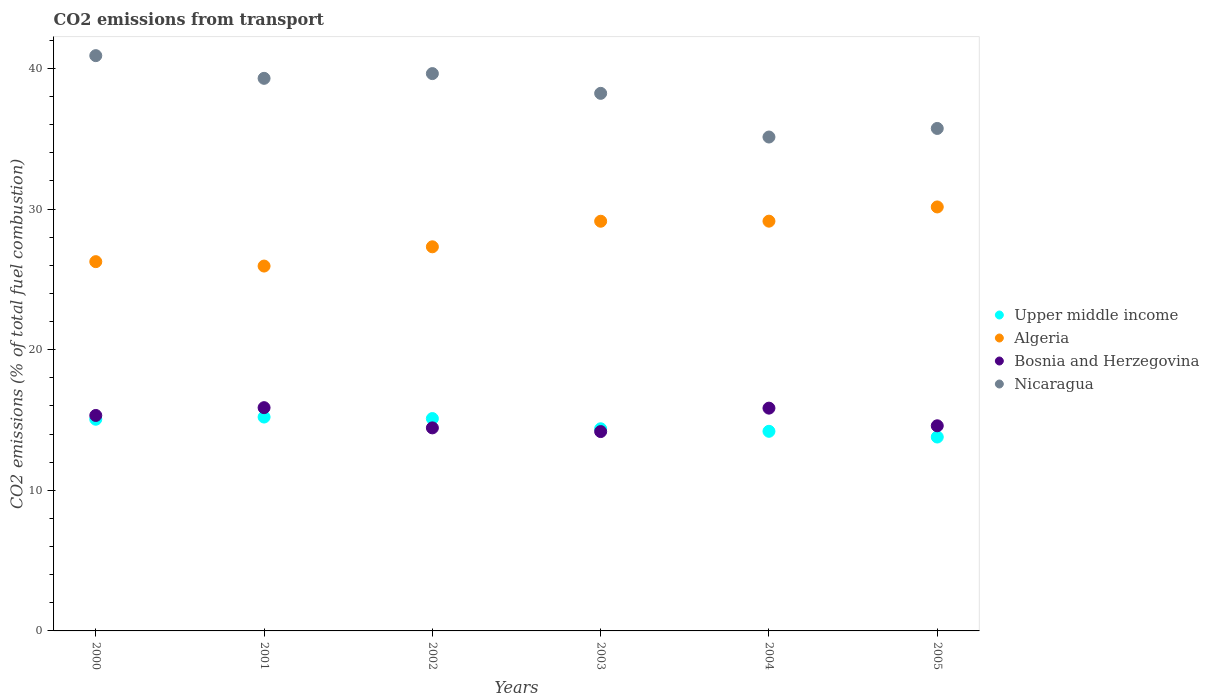How many different coloured dotlines are there?
Offer a very short reply. 4. Is the number of dotlines equal to the number of legend labels?
Your response must be concise. Yes. What is the total CO2 emitted in Algeria in 2003?
Keep it short and to the point. 29.13. Across all years, what is the maximum total CO2 emitted in Algeria?
Make the answer very short. 30.15. Across all years, what is the minimum total CO2 emitted in Upper middle income?
Ensure brevity in your answer.  13.79. In which year was the total CO2 emitted in Bosnia and Herzegovina maximum?
Your answer should be very brief. 2001. In which year was the total CO2 emitted in Algeria minimum?
Provide a succinct answer. 2001. What is the total total CO2 emitted in Bosnia and Herzegovina in the graph?
Make the answer very short. 90.24. What is the difference between the total CO2 emitted in Bosnia and Herzegovina in 2002 and that in 2003?
Your answer should be very brief. 0.26. What is the difference between the total CO2 emitted in Bosnia and Herzegovina in 2004 and the total CO2 emitted in Upper middle income in 2005?
Provide a succinct answer. 2.05. What is the average total CO2 emitted in Algeria per year?
Ensure brevity in your answer.  27.99. In the year 2000, what is the difference between the total CO2 emitted in Nicaragua and total CO2 emitted in Algeria?
Your answer should be compact. 14.65. In how many years, is the total CO2 emitted in Bosnia and Herzegovina greater than 24?
Provide a succinct answer. 0. What is the ratio of the total CO2 emitted in Algeria in 2001 to that in 2005?
Provide a short and direct response. 0.86. Is the difference between the total CO2 emitted in Nicaragua in 2001 and 2004 greater than the difference between the total CO2 emitted in Algeria in 2001 and 2004?
Give a very brief answer. Yes. What is the difference between the highest and the second highest total CO2 emitted in Nicaragua?
Provide a short and direct response. 1.28. What is the difference between the highest and the lowest total CO2 emitted in Bosnia and Herzegovina?
Your answer should be very brief. 1.7. Is the sum of the total CO2 emitted in Algeria in 2001 and 2003 greater than the maximum total CO2 emitted in Nicaragua across all years?
Keep it short and to the point. Yes. Is it the case that in every year, the sum of the total CO2 emitted in Nicaragua and total CO2 emitted in Bosnia and Herzegovina  is greater than the total CO2 emitted in Upper middle income?
Offer a terse response. Yes. Does the total CO2 emitted in Nicaragua monotonically increase over the years?
Ensure brevity in your answer.  No. Is the total CO2 emitted in Bosnia and Herzegovina strictly greater than the total CO2 emitted in Upper middle income over the years?
Offer a very short reply. No. How many dotlines are there?
Offer a terse response. 4. What is the difference between two consecutive major ticks on the Y-axis?
Provide a short and direct response. 10. How many legend labels are there?
Make the answer very short. 4. How are the legend labels stacked?
Your answer should be compact. Vertical. What is the title of the graph?
Your response must be concise. CO2 emissions from transport. What is the label or title of the Y-axis?
Ensure brevity in your answer.  CO2 emissions (% of total fuel combustion). What is the CO2 emissions (% of total fuel combustion) of Upper middle income in 2000?
Offer a very short reply. 15.05. What is the CO2 emissions (% of total fuel combustion) of Algeria in 2000?
Offer a very short reply. 26.26. What is the CO2 emissions (% of total fuel combustion) in Bosnia and Herzegovina in 2000?
Give a very brief answer. 15.32. What is the CO2 emissions (% of total fuel combustion) of Nicaragua in 2000?
Your response must be concise. 40.91. What is the CO2 emissions (% of total fuel combustion) in Upper middle income in 2001?
Keep it short and to the point. 15.21. What is the CO2 emissions (% of total fuel combustion) of Algeria in 2001?
Provide a short and direct response. 25.95. What is the CO2 emissions (% of total fuel combustion) of Bosnia and Herzegovina in 2001?
Give a very brief answer. 15.88. What is the CO2 emissions (% of total fuel combustion) in Nicaragua in 2001?
Provide a succinct answer. 39.3. What is the CO2 emissions (% of total fuel combustion) in Upper middle income in 2002?
Provide a succinct answer. 15.1. What is the CO2 emissions (% of total fuel combustion) in Algeria in 2002?
Ensure brevity in your answer.  27.32. What is the CO2 emissions (% of total fuel combustion) of Bosnia and Herzegovina in 2002?
Keep it short and to the point. 14.44. What is the CO2 emissions (% of total fuel combustion) in Nicaragua in 2002?
Your response must be concise. 39.63. What is the CO2 emissions (% of total fuel combustion) in Upper middle income in 2003?
Your response must be concise. 14.38. What is the CO2 emissions (% of total fuel combustion) in Algeria in 2003?
Offer a very short reply. 29.13. What is the CO2 emissions (% of total fuel combustion) in Bosnia and Herzegovina in 2003?
Offer a very short reply. 14.18. What is the CO2 emissions (% of total fuel combustion) in Nicaragua in 2003?
Make the answer very short. 38.23. What is the CO2 emissions (% of total fuel combustion) in Upper middle income in 2004?
Keep it short and to the point. 14.2. What is the CO2 emissions (% of total fuel combustion) of Algeria in 2004?
Offer a terse response. 29.14. What is the CO2 emissions (% of total fuel combustion) in Bosnia and Herzegovina in 2004?
Provide a short and direct response. 15.84. What is the CO2 emissions (% of total fuel combustion) of Nicaragua in 2004?
Make the answer very short. 35.12. What is the CO2 emissions (% of total fuel combustion) of Upper middle income in 2005?
Ensure brevity in your answer.  13.79. What is the CO2 emissions (% of total fuel combustion) of Algeria in 2005?
Make the answer very short. 30.15. What is the CO2 emissions (% of total fuel combustion) of Bosnia and Herzegovina in 2005?
Offer a very short reply. 14.59. What is the CO2 emissions (% of total fuel combustion) in Nicaragua in 2005?
Offer a very short reply. 35.73. Across all years, what is the maximum CO2 emissions (% of total fuel combustion) in Upper middle income?
Make the answer very short. 15.21. Across all years, what is the maximum CO2 emissions (% of total fuel combustion) in Algeria?
Your answer should be compact. 30.15. Across all years, what is the maximum CO2 emissions (% of total fuel combustion) of Bosnia and Herzegovina?
Provide a succinct answer. 15.88. Across all years, what is the maximum CO2 emissions (% of total fuel combustion) in Nicaragua?
Your answer should be compact. 40.91. Across all years, what is the minimum CO2 emissions (% of total fuel combustion) of Upper middle income?
Keep it short and to the point. 13.79. Across all years, what is the minimum CO2 emissions (% of total fuel combustion) in Algeria?
Give a very brief answer. 25.95. Across all years, what is the minimum CO2 emissions (% of total fuel combustion) of Bosnia and Herzegovina?
Your answer should be compact. 14.18. Across all years, what is the minimum CO2 emissions (% of total fuel combustion) of Nicaragua?
Your response must be concise. 35.12. What is the total CO2 emissions (% of total fuel combustion) in Upper middle income in the graph?
Your answer should be compact. 87.72. What is the total CO2 emissions (% of total fuel combustion) in Algeria in the graph?
Provide a short and direct response. 167.94. What is the total CO2 emissions (% of total fuel combustion) of Bosnia and Herzegovina in the graph?
Give a very brief answer. 90.24. What is the total CO2 emissions (% of total fuel combustion) in Nicaragua in the graph?
Keep it short and to the point. 228.92. What is the difference between the CO2 emissions (% of total fuel combustion) in Upper middle income in 2000 and that in 2001?
Offer a very short reply. -0.16. What is the difference between the CO2 emissions (% of total fuel combustion) of Algeria in 2000 and that in 2001?
Give a very brief answer. 0.31. What is the difference between the CO2 emissions (% of total fuel combustion) of Bosnia and Herzegovina in 2000 and that in 2001?
Provide a short and direct response. -0.55. What is the difference between the CO2 emissions (% of total fuel combustion) in Nicaragua in 2000 and that in 2001?
Your answer should be compact. 1.61. What is the difference between the CO2 emissions (% of total fuel combustion) of Upper middle income in 2000 and that in 2002?
Offer a very short reply. -0.05. What is the difference between the CO2 emissions (% of total fuel combustion) of Algeria in 2000 and that in 2002?
Offer a very short reply. -1.06. What is the difference between the CO2 emissions (% of total fuel combustion) of Bosnia and Herzegovina in 2000 and that in 2002?
Your response must be concise. 0.88. What is the difference between the CO2 emissions (% of total fuel combustion) of Nicaragua in 2000 and that in 2002?
Offer a very short reply. 1.28. What is the difference between the CO2 emissions (% of total fuel combustion) in Upper middle income in 2000 and that in 2003?
Make the answer very short. 0.68. What is the difference between the CO2 emissions (% of total fuel combustion) in Algeria in 2000 and that in 2003?
Give a very brief answer. -2.87. What is the difference between the CO2 emissions (% of total fuel combustion) of Bosnia and Herzegovina in 2000 and that in 2003?
Your answer should be very brief. 1.15. What is the difference between the CO2 emissions (% of total fuel combustion) in Nicaragua in 2000 and that in 2003?
Offer a terse response. 2.68. What is the difference between the CO2 emissions (% of total fuel combustion) in Upper middle income in 2000 and that in 2004?
Your response must be concise. 0.86. What is the difference between the CO2 emissions (% of total fuel combustion) of Algeria in 2000 and that in 2004?
Provide a succinct answer. -2.88. What is the difference between the CO2 emissions (% of total fuel combustion) of Bosnia and Herzegovina in 2000 and that in 2004?
Provide a short and direct response. -0.52. What is the difference between the CO2 emissions (% of total fuel combustion) in Nicaragua in 2000 and that in 2004?
Offer a terse response. 5.79. What is the difference between the CO2 emissions (% of total fuel combustion) in Upper middle income in 2000 and that in 2005?
Your answer should be very brief. 1.26. What is the difference between the CO2 emissions (% of total fuel combustion) in Algeria in 2000 and that in 2005?
Your response must be concise. -3.89. What is the difference between the CO2 emissions (% of total fuel combustion) in Bosnia and Herzegovina in 2000 and that in 2005?
Keep it short and to the point. 0.73. What is the difference between the CO2 emissions (% of total fuel combustion) of Nicaragua in 2000 and that in 2005?
Ensure brevity in your answer.  5.18. What is the difference between the CO2 emissions (% of total fuel combustion) of Upper middle income in 2001 and that in 2002?
Make the answer very short. 0.11. What is the difference between the CO2 emissions (% of total fuel combustion) in Algeria in 2001 and that in 2002?
Provide a short and direct response. -1.37. What is the difference between the CO2 emissions (% of total fuel combustion) of Bosnia and Herzegovina in 2001 and that in 2002?
Your response must be concise. 1.44. What is the difference between the CO2 emissions (% of total fuel combustion) of Nicaragua in 2001 and that in 2002?
Keep it short and to the point. -0.34. What is the difference between the CO2 emissions (% of total fuel combustion) of Upper middle income in 2001 and that in 2003?
Keep it short and to the point. 0.83. What is the difference between the CO2 emissions (% of total fuel combustion) of Algeria in 2001 and that in 2003?
Provide a succinct answer. -3.19. What is the difference between the CO2 emissions (% of total fuel combustion) in Bosnia and Herzegovina in 2001 and that in 2003?
Keep it short and to the point. 1.7. What is the difference between the CO2 emissions (% of total fuel combustion) of Nicaragua in 2001 and that in 2003?
Give a very brief answer. 1.07. What is the difference between the CO2 emissions (% of total fuel combustion) of Upper middle income in 2001 and that in 2004?
Your response must be concise. 1.01. What is the difference between the CO2 emissions (% of total fuel combustion) in Algeria in 2001 and that in 2004?
Give a very brief answer. -3.19. What is the difference between the CO2 emissions (% of total fuel combustion) of Bosnia and Herzegovina in 2001 and that in 2004?
Offer a very short reply. 0.03. What is the difference between the CO2 emissions (% of total fuel combustion) in Nicaragua in 2001 and that in 2004?
Ensure brevity in your answer.  4.17. What is the difference between the CO2 emissions (% of total fuel combustion) of Upper middle income in 2001 and that in 2005?
Provide a succinct answer. 1.42. What is the difference between the CO2 emissions (% of total fuel combustion) of Algeria in 2001 and that in 2005?
Keep it short and to the point. -4.2. What is the difference between the CO2 emissions (% of total fuel combustion) in Bosnia and Herzegovina in 2001 and that in 2005?
Your answer should be compact. 1.29. What is the difference between the CO2 emissions (% of total fuel combustion) of Nicaragua in 2001 and that in 2005?
Your answer should be compact. 3.56. What is the difference between the CO2 emissions (% of total fuel combustion) of Upper middle income in 2002 and that in 2003?
Your response must be concise. 0.73. What is the difference between the CO2 emissions (% of total fuel combustion) of Algeria in 2002 and that in 2003?
Give a very brief answer. -1.82. What is the difference between the CO2 emissions (% of total fuel combustion) in Bosnia and Herzegovina in 2002 and that in 2003?
Offer a very short reply. 0.26. What is the difference between the CO2 emissions (% of total fuel combustion) in Nicaragua in 2002 and that in 2003?
Your response must be concise. 1.4. What is the difference between the CO2 emissions (% of total fuel combustion) of Upper middle income in 2002 and that in 2004?
Provide a succinct answer. 0.91. What is the difference between the CO2 emissions (% of total fuel combustion) of Algeria in 2002 and that in 2004?
Keep it short and to the point. -1.82. What is the difference between the CO2 emissions (% of total fuel combustion) of Bosnia and Herzegovina in 2002 and that in 2004?
Your response must be concise. -1.4. What is the difference between the CO2 emissions (% of total fuel combustion) of Nicaragua in 2002 and that in 2004?
Provide a short and direct response. 4.51. What is the difference between the CO2 emissions (% of total fuel combustion) in Upper middle income in 2002 and that in 2005?
Make the answer very short. 1.31. What is the difference between the CO2 emissions (% of total fuel combustion) in Algeria in 2002 and that in 2005?
Make the answer very short. -2.83. What is the difference between the CO2 emissions (% of total fuel combustion) of Bosnia and Herzegovina in 2002 and that in 2005?
Provide a succinct answer. -0.15. What is the difference between the CO2 emissions (% of total fuel combustion) in Nicaragua in 2002 and that in 2005?
Offer a terse response. 3.9. What is the difference between the CO2 emissions (% of total fuel combustion) in Upper middle income in 2003 and that in 2004?
Offer a terse response. 0.18. What is the difference between the CO2 emissions (% of total fuel combustion) of Algeria in 2003 and that in 2004?
Your answer should be compact. -0. What is the difference between the CO2 emissions (% of total fuel combustion) in Bosnia and Herzegovina in 2003 and that in 2004?
Provide a short and direct response. -1.67. What is the difference between the CO2 emissions (% of total fuel combustion) of Nicaragua in 2003 and that in 2004?
Ensure brevity in your answer.  3.11. What is the difference between the CO2 emissions (% of total fuel combustion) in Upper middle income in 2003 and that in 2005?
Your answer should be very brief. 0.59. What is the difference between the CO2 emissions (% of total fuel combustion) of Algeria in 2003 and that in 2005?
Your answer should be very brief. -1.02. What is the difference between the CO2 emissions (% of total fuel combustion) of Bosnia and Herzegovina in 2003 and that in 2005?
Offer a very short reply. -0.41. What is the difference between the CO2 emissions (% of total fuel combustion) of Nicaragua in 2003 and that in 2005?
Offer a terse response. 2.5. What is the difference between the CO2 emissions (% of total fuel combustion) in Upper middle income in 2004 and that in 2005?
Your answer should be very brief. 0.41. What is the difference between the CO2 emissions (% of total fuel combustion) of Algeria in 2004 and that in 2005?
Ensure brevity in your answer.  -1.01. What is the difference between the CO2 emissions (% of total fuel combustion) in Bosnia and Herzegovina in 2004 and that in 2005?
Offer a terse response. 1.25. What is the difference between the CO2 emissions (% of total fuel combustion) in Nicaragua in 2004 and that in 2005?
Provide a succinct answer. -0.61. What is the difference between the CO2 emissions (% of total fuel combustion) in Upper middle income in 2000 and the CO2 emissions (% of total fuel combustion) in Algeria in 2001?
Give a very brief answer. -10.89. What is the difference between the CO2 emissions (% of total fuel combustion) of Upper middle income in 2000 and the CO2 emissions (% of total fuel combustion) of Bosnia and Herzegovina in 2001?
Make the answer very short. -0.82. What is the difference between the CO2 emissions (% of total fuel combustion) in Upper middle income in 2000 and the CO2 emissions (% of total fuel combustion) in Nicaragua in 2001?
Your answer should be compact. -24.24. What is the difference between the CO2 emissions (% of total fuel combustion) in Algeria in 2000 and the CO2 emissions (% of total fuel combustion) in Bosnia and Herzegovina in 2001?
Offer a very short reply. 10.38. What is the difference between the CO2 emissions (% of total fuel combustion) in Algeria in 2000 and the CO2 emissions (% of total fuel combustion) in Nicaragua in 2001?
Offer a very short reply. -13.04. What is the difference between the CO2 emissions (% of total fuel combustion) in Bosnia and Herzegovina in 2000 and the CO2 emissions (% of total fuel combustion) in Nicaragua in 2001?
Give a very brief answer. -23.97. What is the difference between the CO2 emissions (% of total fuel combustion) of Upper middle income in 2000 and the CO2 emissions (% of total fuel combustion) of Algeria in 2002?
Offer a terse response. -12.26. What is the difference between the CO2 emissions (% of total fuel combustion) in Upper middle income in 2000 and the CO2 emissions (% of total fuel combustion) in Bosnia and Herzegovina in 2002?
Your response must be concise. 0.61. What is the difference between the CO2 emissions (% of total fuel combustion) of Upper middle income in 2000 and the CO2 emissions (% of total fuel combustion) of Nicaragua in 2002?
Ensure brevity in your answer.  -24.58. What is the difference between the CO2 emissions (% of total fuel combustion) of Algeria in 2000 and the CO2 emissions (% of total fuel combustion) of Bosnia and Herzegovina in 2002?
Provide a succinct answer. 11.82. What is the difference between the CO2 emissions (% of total fuel combustion) in Algeria in 2000 and the CO2 emissions (% of total fuel combustion) in Nicaragua in 2002?
Provide a short and direct response. -13.37. What is the difference between the CO2 emissions (% of total fuel combustion) of Bosnia and Herzegovina in 2000 and the CO2 emissions (% of total fuel combustion) of Nicaragua in 2002?
Your answer should be very brief. -24.31. What is the difference between the CO2 emissions (% of total fuel combustion) of Upper middle income in 2000 and the CO2 emissions (% of total fuel combustion) of Algeria in 2003?
Give a very brief answer. -14.08. What is the difference between the CO2 emissions (% of total fuel combustion) in Upper middle income in 2000 and the CO2 emissions (% of total fuel combustion) in Bosnia and Herzegovina in 2003?
Keep it short and to the point. 0.88. What is the difference between the CO2 emissions (% of total fuel combustion) in Upper middle income in 2000 and the CO2 emissions (% of total fuel combustion) in Nicaragua in 2003?
Your answer should be very brief. -23.17. What is the difference between the CO2 emissions (% of total fuel combustion) in Algeria in 2000 and the CO2 emissions (% of total fuel combustion) in Bosnia and Herzegovina in 2003?
Offer a very short reply. 12.08. What is the difference between the CO2 emissions (% of total fuel combustion) of Algeria in 2000 and the CO2 emissions (% of total fuel combustion) of Nicaragua in 2003?
Make the answer very short. -11.97. What is the difference between the CO2 emissions (% of total fuel combustion) in Bosnia and Herzegovina in 2000 and the CO2 emissions (% of total fuel combustion) in Nicaragua in 2003?
Offer a terse response. -22.91. What is the difference between the CO2 emissions (% of total fuel combustion) in Upper middle income in 2000 and the CO2 emissions (% of total fuel combustion) in Algeria in 2004?
Provide a succinct answer. -14.09. What is the difference between the CO2 emissions (% of total fuel combustion) in Upper middle income in 2000 and the CO2 emissions (% of total fuel combustion) in Bosnia and Herzegovina in 2004?
Provide a succinct answer. -0.79. What is the difference between the CO2 emissions (% of total fuel combustion) of Upper middle income in 2000 and the CO2 emissions (% of total fuel combustion) of Nicaragua in 2004?
Your answer should be compact. -20.07. What is the difference between the CO2 emissions (% of total fuel combustion) in Algeria in 2000 and the CO2 emissions (% of total fuel combustion) in Bosnia and Herzegovina in 2004?
Give a very brief answer. 10.42. What is the difference between the CO2 emissions (% of total fuel combustion) of Algeria in 2000 and the CO2 emissions (% of total fuel combustion) of Nicaragua in 2004?
Provide a short and direct response. -8.86. What is the difference between the CO2 emissions (% of total fuel combustion) in Bosnia and Herzegovina in 2000 and the CO2 emissions (% of total fuel combustion) in Nicaragua in 2004?
Keep it short and to the point. -19.8. What is the difference between the CO2 emissions (% of total fuel combustion) in Upper middle income in 2000 and the CO2 emissions (% of total fuel combustion) in Algeria in 2005?
Your answer should be very brief. -15.1. What is the difference between the CO2 emissions (% of total fuel combustion) of Upper middle income in 2000 and the CO2 emissions (% of total fuel combustion) of Bosnia and Herzegovina in 2005?
Your answer should be compact. 0.47. What is the difference between the CO2 emissions (% of total fuel combustion) in Upper middle income in 2000 and the CO2 emissions (% of total fuel combustion) in Nicaragua in 2005?
Give a very brief answer. -20.68. What is the difference between the CO2 emissions (% of total fuel combustion) of Algeria in 2000 and the CO2 emissions (% of total fuel combustion) of Bosnia and Herzegovina in 2005?
Offer a very short reply. 11.67. What is the difference between the CO2 emissions (% of total fuel combustion) of Algeria in 2000 and the CO2 emissions (% of total fuel combustion) of Nicaragua in 2005?
Provide a succinct answer. -9.47. What is the difference between the CO2 emissions (% of total fuel combustion) in Bosnia and Herzegovina in 2000 and the CO2 emissions (% of total fuel combustion) in Nicaragua in 2005?
Provide a succinct answer. -20.41. What is the difference between the CO2 emissions (% of total fuel combustion) in Upper middle income in 2001 and the CO2 emissions (% of total fuel combustion) in Algeria in 2002?
Make the answer very short. -12.11. What is the difference between the CO2 emissions (% of total fuel combustion) in Upper middle income in 2001 and the CO2 emissions (% of total fuel combustion) in Bosnia and Herzegovina in 2002?
Your answer should be compact. 0.77. What is the difference between the CO2 emissions (% of total fuel combustion) of Upper middle income in 2001 and the CO2 emissions (% of total fuel combustion) of Nicaragua in 2002?
Keep it short and to the point. -24.42. What is the difference between the CO2 emissions (% of total fuel combustion) of Algeria in 2001 and the CO2 emissions (% of total fuel combustion) of Bosnia and Herzegovina in 2002?
Give a very brief answer. 11.51. What is the difference between the CO2 emissions (% of total fuel combustion) of Algeria in 2001 and the CO2 emissions (% of total fuel combustion) of Nicaragua in 2002?
Keep it short and to the point. -13.69. What is the difference between the CO2 emissions (% of total fuel combustion) of Bosnia and Herzegovina in 2001 and the CO2 emissions (% of total fuel combustion) of Nicaragua in 2002?
Ensure brevity in your answer.  -23.76. What is the difference between the CO2 emissions (% of total fuel combustion) in Upper middle income in 2001 and the CO2 emissions (% of total fuel combustion) in Algeria in 2003?
Offer a very short reply. -13.92. What is the difference between the CO2 emissions (% of total fuel combustion) of Upper middle income in 2001 and the CO2 emissions (% of total fuel combustion) of Bosnia and Herzegovina in 2003?
Your answer should be very brief. 1.03. What is the difference between the CO2 emissions (% of total fuel combustion) of Upper middle income in 2001 and the CO2 emissions (% of total fuel combustion) of Nicaragua in 2003?
Offer a very short reply. -23.02. What is the difference between the CO2 emissions (% of total fuel combustion) of Algeria in 2001 and the CO2 emissions (% of total fuel combustion) of Bosnia and Herzegovina in 2003?
Offer a terse response. 11.77. What is the difference between the CO2 emissions (% of total fuel combustion) of Algeria in 2001 and the CO2 emissions (% of total fuel combustion) of Nicaragua in 2003?
Provide a short and direct response. -12.28. What is the difference between the CO2 emissions (% of total fuel combustion) of Bosnia and Herzegovina in 2001 and the CO2 emissions (% of total fuel combustion) of Nicaragua in 2003?
Your answer should be very brief. -22.35. What is the difference between the CO2 emissions (% of total fuel combustion) in Upper middle income in 2001 and the CO2 emissions (% of total fuel combustion) in Algeria in 2004?
Your answer should be very brief. -13.93. What is the difference between the CO2 emissions (% of total fuel combustion) in Upper middle income in 2001 and the CO2 emissions (% of total fuel combustion) in Bosnia and Herzegovina in 2004?
Keep it short and to the point. -0.63. What is the difference between the CO2 emissions (% of total fuel combustion) of Upper middle income in 2001 and the CO2 emissions (% of total fuel combustion) of Nicaragua in 2004?
Your answer should be very brief. -19.91. What is the difference between the CO2 emissions (% of total fuel combustion) of Algeria in 2001 and the CO2 emissions (% of total fuel combustion) of Bosnia and Herzegovina in 2004?
Your response must be concise. 10.1. What is the difference between the CO2 emissions (% of total fuel combustion) in Algeria in 2001 and the CO2 emissions (% of total fuel combustion) in Nicaragua in 2004?
Your answer should be very brief. -9.18. What is the difference between the CO2 emissions (% of total fuel combustion) of Bosnia and Herzegovina in 2001 and the CO2 emissions (% of total fuel combustion) of Nicaragua in 2004?
Ensure brevity in your answer.  -19.25. What is the difference between the CO2 emissions (% of total fuel combustion) in Upper middle income in 2001 and the CO2 emissions (% of total fuel combustion) in Algeria in 2005?
Your answer should be compact. -14.94. What is the difference between the CO2 emissions (% of total fuel combustion) of Upper middle income in 2001 and the CO2 emissions (% of total fuel combustion) of Bosnia and Herzegovina in 2005?
Your response must be concise. 0.62. What is the difference between the CO2 emissions (% of total fuel combustion) in Upper middle income in 2001 and the CO2 emissions (% of total fuel combustion) in Nicaragua in 2005?
Give a very brief answer. -20.52. What is the difference between the CO2 emissions (% of total fuel combustion) in Algeria in 2001 and the CO2 emissions (% of total fuel combustion) in Bosnia and Herzegovina in 2005?
Offer a terse response. 11.36. What is the difference between the CO2 emissions (% of total fuel combustion) of Algeria in 2001 and the CO2 emissions (% of total fuel combustion) of Nicaragua in 2005?
Provide a succinct answer. -9.79. What is the difference between the CO2 emissions (% of total fuel combustion) of Bosnia and Herzegovina in 2001 and the CO2 emissions (% of total fuel combustion) of Nicaragua in 2005?
Provide a succinct answer. -19.86. What is the difference between the CO2 emissions (% of total fuel combustion) in Upper middle income in 2002 and the CO2 emissions (% of total fuel combustion) in Algeria in 2003?
Provide a succinct answer. -14.03. What is the difference between the CO2 emissions (% of total fuel combustion) in Upper middle income in 2002 and the CO2 emissions (% of total fuel combustion) in Bosnia and Herzegovina in 2003?
Offer a terse response. 0.92. What is the difference between the CO2 emissions (% of total fuel combustion) in Upper middle income in 2002 and the CO2 emissions (% of total fuel combustion) in Nicaragua in 2003?
Your answer should be very brief. -23.13. What is the difference between the CO2 emissions (% of total fuel combustion) of Algeria in 2002 and the CO2 emissions (% of total fuel combustion) of Bosnia and Herzegovina in 2003?
Provide a short and direct response. 13.14. What is the difference between the CO2 emissions (% of total fuel combustion) in Algeria in 2002 and the CO2 emissions (% of total fuel combustion) in Nicaragua in 2003?
Give a very brief answer. -10.91. What is the difference between the CO2 emissions (% of total fuel combustion) in Bosnia and Herzegovina in 2002 and the CO2 emissions (% of total fuel combustion) in Nicaragua in 2003?
Provide a short and direct response. -23.79. What is the difference between the CO2 emissions (% of total fuel combustion) in Upper middle income in 2002 and the CO2 emissions (% of total fuel combustion) in Algeria in 2004?
Your answer should be compact. -14.04. What is the difference between the CO2 emissions (% of total fuel combustion) in Upper middle income in 2002 and the CO2 emissions (% of total fuel combustion) in Bosnia and Herzegovina in 2004?
Offer a very short reply. -0.74. What is the difference between the CO2 emissions (% of total fuel combustion) of Upper middle income in 2002 and the CO2 emissions (% of total fuel combustion) of Nicaragua in 2004?
Your response must be concise. -20.02. What is the difference between the CO2 emissions (% of total fuel combustion) of Algeria in 2002 and the CO2 emissions (% of total fuel combustion) of Bosnia and Herzegovina in 2004?
Provide a succinct answer. 11.47. What is the difference between the CO2 emissions (% of total fuel combustion) of Algeria in 2002 and the CO2 emissions (% of total fuel combustion) of Nicaragua in 2004?
Your answer should be very brief. -7.81. What is the difference between the CO2 emissions (% of total fuel combustion) in Bosnia and Herzegovina in 2002 and the CO2 emissions (% of total fuel combustion) in Nicaragua in 2004?
Make the answer very short. -20.68. What is the difference between the CO2 emissions (% of total fuel combustion) in Upper middle income in 2002 and the CO2 emissions (% of total fuel combustion) in Algeria in 2005?
Provide a succinct answer. -15.05. What is the difference between the CO2 emissions (% of total fuel combustion) in Upper middle income in 2002 and the CO2 emissions (% of total fuel combustion) in Bosnia and Herzegovina in 2005?
Your answer should be very brief. 0.51. What is the difference between the CO2 emissions (% of total fuel combustion) of Upper middle income in 2002 and the CO2 emissions (% of total fuel combustion) of Nicaragua in 2005?
Provide a short and direct response. -20.63. What is the difference between the CO2 emissions (% of total fuel combustion) of Algeria in 2002 and the CO2 emissions (% of total fuel combustion) of Bosnia and Herzegovina in 2005?
Make the answer very short. 12.73. What is the difference between the CO2 emissions (% of total fuel combustion) of Algeria in 2002 and the CO2 emissions (% of total fuel combustion) of Nicaragua in 2005?
Your answer should be very brief. -8.42. What is the difference between the CO2 emissions (% of total fuel combustion) in Bosnia and Herzegovina in 2002 and the CO2 emissions (% of total fuel combustion) in Nicaragua in 2005?
Provide a short and direct response. -21.29. What is the difference between the CO2 emissions (% of total fuel combustion) of Upper middle income in 2003 and the CO2 emissions (% of total fuel combustion) of Algeria in 2004?
Provide a short and direct response. -14.76. What is the difference between the CO2 emissions (% of total fuel combustion) of Upper middle income in 2003 and the CO2 emissions (% of total fuel combustion) of Bosnia and Herzegovina in 2004?
Keep it short and to the point. -1.47. What is the difference between the CO2 emissions (% of total fuel combustion) in Upper middle income in 2003 and the CO2 emissions (% of total fuel combustion) in Nicaragua in 2004?
Keep it short and to the point. -20.75. What is the difference between the CO2 emissions (% of total fuel combustion) in Algeria in 2003 and the CO2 emissions (% of total fuel combustion) in Bosnia and Herzegovina in 2004?
Give a very brief answer. 13.29. What is the difference between the CO2 emissions (% of total fuel combustion) of Algeria in 2003 and the CO2 emissions (% of total fuel combustion) of Nicaragua in 2004?
Make the answer very short. -5.99. What is the difference between the CO2 emissions (% of total fuel combustion) of Bosnia and Herzegovina in 2003 and the CO2 emissions (% of total fuel combustion) of Nicaragua in 2004?
Offer a terse response. -20.95. What is the difference between the CO2 emissions (% of total fuel combustion) of Upper middle income in 2003 and the CO2 emissions (% of total fuel combustion) of Algeria in 2005?
Keep it short and to the point. -15.77. What is the difference between the CO2 emissions (% of total fuel combustion) of Upper middle income in 2003 and the CO2 emissions (% of total fuel combustion) of Bosnia and Herzegovina in 2005?
Keep it short and to the point. -0.21. What is the difference between the CO2 emissions (% of total fuel combustion) of Upper middle income in 2003 and the CO2 emissions (% of total fuel combustion) of Nicaragua in 2005?
Provide a succinct answer. -21.36. What is the difference between the CO2 emissions (% of total fuel combustion) in Algeria in 2003 and the CO2 emissions (% of total fuel combustion) in Bosnia and Herzegovina in 2005?
Ensure brevity in your answer.  14.55. What is the difference between the CO2 emissions (% of total fuel combustion) in Algeria in 2003 and the CO2 emissions (% of total fuel combustion) in Nicaragua in 2005?
Provide a short and direct response. -6.6. What is the difference between the CO2 emissions (% of total fuel combustion) of Bosnia and Herzegovina in 2003 and the CO2 emissions (% of total fuel combustion) of Nicaragua in 2005?
Make the answer very short. -21.56. What is the difference between the CO2 emissions (% of total fuel combustion) of Upper middle income in 2004 and the CO2 emissions (% of total fuel combustion) of Algeria in 2005?
Ensure brevity in your answer.  -15.95. What is the difference between the CO2 emissions (% of total fuel combustion) in Upper middle income in 2004 and the CO2 emissions (% of total fuel combustion) in Bosnia and Herzegovina in 2005?
Make the answer very short. -0.39. What is the difference between the CO2 emissions (% of total fuel combustion) in Upper middle income in 2004 and the CO2 emissions (% of total fuel combustion) in Nicaragua in 2005?
Your answer should be very brief. -21.54. What is the difference between the CO2 emissions (% of total fuel combustion) of Algeria in 2004 and the CO2 emissions (% of total fuel combustion) of Bosnia and Herzegovina in 2005?
Your response must be concise. 14.55. What is the difference between the CO2 emissions (% of total fuel combustion) of Algeria in 2004 and the CO2 emissions (% of total fuel combustion) of Nicaragua in 2005?
Make the answer very short. -6.59. What is the difference between the CO2 emissions (% of total fuel combustion) of Bosnia and Herzegovina in 2004 and the CO2 emissions (% of total fuel combustion) of Nicaragua in 2005?
Your answer should be compact. -19.89. What is the average CO2 emissions (% of total fuel combustion) in Upper middle income per year?
Offer a very short reply. 14.62. What is the average CO2 emissions (% of total fuel combustion) in Algeria per year?
Offer a terse response. 27.99. What is the average CO2 emissions (% of total fuel combustion) in Bosnia and Herzegovina per year?
Provide a succinct answer. 15.04. What is the average CO2 emissions (% of total fuel combustion) in Nicaragua per year?
Make the answer very short. 38.15. In the year 2000, what is the difference between the CO2 emissions (% of total fuel combustion) of Upper middle income and CO2 emissions (% of total fuel combustion) of Algeria?
Ensure brevity in your answer.  -11.21. In the year 2000, what is the difference between the CO2 emissions (% of total fuel combustion) in Upper middle income and CO2 emissions (% of total fuel combustion) in Bosnia and Herzegovina?
Keep it short and to the point. -0.27. In the year 2000, what is the difference between the CO2 emissions (% of total fuel combustion) of Upper middle income and CO2 emissions (% of total fuel combustion) of Nicaragua?
Make the answer very short. -25.86. In the year 2000, what is the difference between the CO2 emissions (% of total fuel combustion) in Algeria and CO2 emissions (% of total fuel combustion) in Bosnia and Herzegovina?
Give a very brief answer. 10.94. In the year 2000, what is the difference between the CO2 emissions (% of total fuel combustion) in Algeria and CO2 emissions (% of total fuel combustion) in Nicaragua?
Your answer should be compact. -14.65. In the year 2000, what is the difference between the CO2 emissions (% of total fuel combustion) of Bosnia and Herzegovina and CO2 emissions (% of total fuel combustion) of Nicaragua?
Ensure brevity in your answer.  -25.59. In the year 2001, what is the difference between the CO2 emissions (% of total fuel combustion) of Upper middle income and CO2 emissions (% of total fuel combustion) of Algeria?
Your response must be concise. -10.74. In the year 2001, what is the difference between the CO2 emissions (% of total fuel combustion) in Upper middle income and CO2 emissions (% of total fuel combustion) in Bosnia and Herzegovina?
Your response must be concise. -0.67. In the year 2001, what is the difference between the CO2 emissions (% of total fuel combustion) in Upper middle income and CO2 emissions (% of total fuel combustion) in Nicaragua?
Make the answer very short. -24.09. In the year 2001, what is the difference between the CO2 emissions (% of total fuel combustion) in Algeria and CO2 emissions (% of total fuel combustion) in Bosnia and Herzegovina?
Offer a very short reply. 10.07. In the year 2001, what is the difference between the CO2 emissions (% of total fuel combustion) in Algeria and CO2 emissions (% of total fuel combustion) in Nicaragua?
Ensure brevity in your answer.  -13.35. In the year 2001, what is the difference between the CO2 emissions (% of total fuel combustion) of Bosnia and Herzegovina and CO2 emissions (% of total fuel combustion) of Nicaragua?
Make the answer very short. -23.42. In the year 2002, what is the difference between the CO2 emissions (% of total fuel combustion) in Upper middle income and CO2 emissions (% of total fuel combustion) in Algeria?
Give a very brief answer. -12.21. In the year 2002, what is the difference between the CO2 emissions (% of total fuel combustion) in Upper middle income and CO2 emissions (% of total fuel combustion) in Bosnia and Herzegovina?
Give a very brief answer. 0.66. In the year 2002, what is the difference between the CO2 emissions (% of total fuel combustion) in Upper middle income and CO2 emissions (% of total fuel combustion) in Nicaragua?
Ensure brevity in your answer.  -24.53. In the year 2002, what is the difference between the CO2 emissions (% of total fuel combustion) in Algeria and CO2 emissions (% of total fuel combustion) in Bosnia and Herzegovina?
Offer a terse response. 12.88. In the year 2002, what is the difference between the CO2 emissions (% of total fuel combustion) in Algeria and CO2 emissions (% of total fuel combustion) in Nicaragua?
Make the answer very short. -12.32. In the year 2002, what is the difference between the CO2 emissions (% of total fuel combustion) of Bosnia and Herzegovina and CO2 emissions (% of total fuel combustion) of Nicaragua?
Keep it short and to the point. -25.19. In the year 2003, what is the difference between the CO2 emissions (% of total fuel combustion) of Upper middle income and CO2 emissions (% of total fuel combustion) of Algeria?
Provide a short and direct response. -14.76. In the year 2003, what is the difference between the CO2 emissions (% of total fuel combustion) in Upper middle income and CO2 emissions (% of total fuel combustion) in Bosnia and Herzegovina?
Provide a short and direct response. 0.2. In the year 2003, what is the difference between the CO2 emissions (% of total fuel combustion) in Upper middle income and CO2 emissions (% of total fuel combustion) in Nicaragua?
Offer a terse response. -23.85. In the year 2003, what is the difference between the CO2 emissions (% of total fuel combustion) of Algeria and CO2 emissions (% of total fuel combustion) of Bosnia and Herzegovina?
Provide a succinct answer. 14.96. In the year 2003, what is the difference between the CO2 emissions (% of total fuel combustion) of Algeria and CO2 emissions (% of total fuel combustion) of Nicaragua?
Make the answer very short. -9.09. In the year 2003, what is the difference between the CO2 emissions (% of total fuel combustion) of Bosnia and Herzegovina and CO2 emissions (% of total fuel combustion) of Nicaragua?
Offer a very short reply. -24.05. In the year 2004, what is the difference between the CO2 emissions (% of total fuel combustion) in Upper middle income and CO2 emissions (% of total fuel combustion) in Algeria?
Make the answer very short. -14.94. In the year 2004, what is the difference between the CO2 emissions (% of total fuel combustion) of Upper middle income and CO2 emissions (% of total fuel combustion) of Bosnia and Herzegovina?
Offer a terse response. -1.65. In the year 2004, what is the difference between the CO2 emissions (% of total fuel combustion) of Upper middle income and CO2 emissions (% of total fuel combustion) of Nicaragua?
Give a very brief answer. -20.93. In the year 2004, what is the difference between the CO2 emissions (% of total fuel combustion) of Algeria and CO2 emissions (% of total fuel combustion) of Bosnia and Herzegovina?
Provide a short and direct response. 13.3. In the year 2004, what is the difference between the CO2 emissions (% of total fuel combustion) of Algeria and CO2 emissions (% of total fuel combustion) of Nicaragua?
Offer a very short reply. -5.98. In the year 2004, what is the difference between the CO2 emissions (% of total fuel combustion) of Bosnia and Herzegovina and CO2 emissions (% of total fuel combustion) of Nicaragua?
Provide a short and direct response. -19.28. In the year 2005, what is the difference between the CO2 emissions (% of total fuel combustion) of Upper middle income and CO2 emissions (% of total fuel combustion) of Algeria?
Provide a short and direct response. -16.36. In the year 2005, what is the difference between the CO2 emissions (% of total fuel combustion) in Upper middle income and CO2 emissions (% of total fuel combustion) in Bosnia and Herzegovina?
Your answer should be compact. -0.8. In the year 2005, what is the difference between the CO2 emissions (% of total fuel combustion) in Upper middle income and CO2 emissions (% of total fuel combustion) in Nicaragua?
Offer a very short reply. -21.94. In the year 2005, what is the difference between the CO2 emissions (% of total fuel combustion) in Algeria and CO2 emissions (% of total fuel combustion) in Bosnia and Herzegovina?
Keep it short and to the point. 15.56. In the year 2005, what is the difference between the CO2 emissions (% of total fuel combustion) in Algeria and CO2 emissions (% of total fuel combustion) in Nicaragua?
Give a very brief answer. -5.58. In the year 2005, what is the difference between the CO2 emissions (% of total fuel combustion) of Bosnia and Herzegovina and CO2 emissions (% of total fuel combustion) of Nicaragua?
Offer a terse response. -21.14. What is the ratio of the CO2 emissions (% of total fuel combustion) of Algeria in 2000 to that in 2001?
Your response must be concise. 1.01. What is the ratio of the CO2 emissions (% of total fuel combustion) in Bosnia and Herzegovina in 2000 to that in 2001?
Offer a terse response. 0.97. What is the ratio of the CO2 emissions (% of total fuel combustion) in Nicaragua in 2000 to that in 2001?
Ensure brevity in your answer.  1.04. What is the ratio of the CO2 emissions (% of total fuel combustion) in Algeria in 2000 to that in 2002?
Your response must be concise. 0.96. What is the ratio of the CO2 emissions (% of total fuel combustion) of Bosnia and Herzegovina in 2000 to that in 2002?
Provide a short and direct response. 1.06. What is the ratio of the CO2 emissions (% of total fuel combustion) in Nicaragua in 2000 to that in 2002?
Your answer should be compact. 1.03. What is the ratio of the CO2 emissions (% of total fuel combustion) of Upper middle income in 2000 to that in 2003?
Ensure brevity in your answer.  1.05. What is the ratio of the CO2 emissions (% of total fuel combustion) in Algeria in 2000 to that in 2003?
Provide a short and direct response. 0.9. What is the ratio of the CO2 emissions (% of total fuel combustion) of Bosnia and Herzegovina in 2000 to that in 2003?
Ensure brevity in your answer.  1.08. What is the ratio of the CO2 emissions (% of total fuel combustion) in Nicaragua in 2000 to that in 2003?
Provide a succinct answer. 1.07. What is the ratio of the CO2 emissions (% of total fuel combustion) of Upper middle income in 2000 to that in 2004?
Give a very brief answer. 1.06. What is the ratio of the CO2 emissions (% of total fuel combustion) in Algeria in 2000 to that in 2004?
Provide a succinct answer. 0.9. What is the ratio of the CO2 emissions (% of total fuel combustion) in Bosnia and Herzegovina in 2000 to that in 2004?
Your response must be concise. 0.97. What is the ratio of the CO2 emissions (% of total fuel combustion) in Nicaragua in 2000 to that in 2004?
Keep it short and to the point. 1.16. What is the ratio of the CO2 emissions (% of total fuel combustion) in Upper middle income in 2000 to that in 2005?
Your answer should be very brief. 1.09. What is the ratio of the CO2 emissions (% of total fuel combustion) of Algeria in 2000 to that in 2005?
Your answer should be very brief. 0.87. What is the ratio of the CO2 emissions (% of total fuel combustion) in Bosnia and Herzegovina in 2000 to that in 2005?
Provide a succinct answer. 1.05. What is the ratio of the CO2 emissions (% of total fuel combustion) in Nicaragua in 2000 to that in 2005?
Provide a succinct answer. 1.14. What is the ratio of the CO2 emissions (% of total fuel combustion) of Algeria in 2001 to that in 2002?
Offer a very short reply. 0.95. What is the ratio of the CO2 emissions (% of total fuel combustion) in Bosnia and Herzegovina in 2001 to that in 2002?
Make the answer very short. 1.1. What is the ratio of the CO2 emissions (% of total fuel combustion) of Nicaragua in 2001 to that in 2002?
Provide a short and direct response. 0.99. What is the ratio of the CO2 emissions (% of total fuel combustion) of Upper middle income in 2001 to that in 2003?
Your answer should be very brief. 1.06. What is the ratio of the CO2 emissions (% of total fuel combustion) of Algeria in 2001 to that in 2003?
Offer a terse response. 0.89. What is the ratio of the CO2 emissions (% of total fuel combustion) in Bosnia and Herzegovina in 2001 to that in 2003?
Keep it short and to the point. 1.12. What is the ratio of the CO2 emissions (% of total fuel combustion) of Nicaragua in 2001 to that in 2003?
Make the answer very short. 1.03. What is the ratio of the CO2 emissions (% of total fuel combustion) in Upper middle income in 2001 to that in 2004?
Offer a very short reply. 1.07. What is the ratio of the CO2 emissions (% of total fuel combustion) in Algeria in 2001 to that in 2004?
Make the answer very short. 0.89. What is the ratio of the CO2 emissions (% of total fuel combustion) in Bosnia and Herzegovina in 2001 to that in 2004?
Provide a short and direct response. 1. What is the ratio of the CO2 emissions (% of total fuel combustion) of Nicaragua in 2001 to that in 2004?
Ensure brevity in your answer.  1.12. What is the ratio of the CO2 emissions (% of total fuel combustion) in Upper middle income in 2001 to that in 2005?
Offer a terse response. 1.1. What is the ratio of the CO2 emissions (% of total fuel combustion) of Algeria in 2001 to that in 2005?
Make the answer very short. 0.86. What is the ratio of the CO2 emissions (% of total fuel combustion) of Bosnia and Herzegovina in 2001 to that in 2005?
Offer a terse response. 1.09. What is the ratio of the CO2 emissions (% of total fuel combustion) of Nicaragua in 2001 to that in 2005?
Offer a very short reply. 1.1. What is the ratio of the CO2 emissions (% of total fuel combustion) of Upper middle income in 2002 to that in 2003?
Provide a succinct answer. 1.05. What is the ratio of the CO2 emissions (% of total fuel combustion) of Algeria in 2002 to that in 2003?
Make the answer very short. 0.94. What is the ratio of the CO2 emissions (% of total fuel combustion) of Bosnia and Herzegovina in 2002 to that in 2003?
Provide a short and direct response. 1.02. What is the ratio of the CO2 emissions (% of total fuel combustion) of Nicaragua in 2002 to that in 2003?
Your answer should be compact. 1.04. What is the ratio of the CO2 emissions (% of total fuel combustion) of Upper middle income in 2002 to that in 2004?
Offer a very short reply. 1.06. What is the ratio of the CO2 emissions (% of total fuel combustion) of Algeria in 2002 to that in 2004?
Keep it short and to the point. 0.94. What is the ratio of the CO2 emissions (% of total fuel combustion) of Bosnia and Herzegovina in 2002 to that in 2004?
Ensure brevity in your answer.  0.91. What is the ratio of the CO2 emissions (% of total fuel combustion) of Nicaragua in 2002 to that in 2004?
Provide a short and direct response. 1.13. What is the ratio of the CO2 emissions (% of total fuel combustion) of Upper middle income in 2002 to that in 2005?
Provide a short and direct response. 1.1. What is the ratio of the CO2 emissions (% of total fuel combustion) of Algeria in 2002 to that in 2005?
Offer a very short reply. 0.91. What is the ratio of the CO2 emissions (% of total fuel combustion) of Bosnia and Herzegovina in 2002 to that in 2005?
Offer a very short reply. 0.99. What is the ratio of the CO2 emissions (% of total fuel combustion) in Nicaragua in 2002 to that in 2005?
Ensure brevity in your answer.  1.11. What is the ratio of the CO2 emissions (% of total fuel combustion) of Upper middle income in 2003 to that in 2004?
Provide a short and direct response. 1.01. What is the ratio of the CO2 emissions (% of total fuel combustion) of Algeria in 2003 to that in 2004?
Give a very brief answer. 1. What is the ratio of the CO2 emissions (% of total fuel combustion) of Bosnia and Herzegovina in 2003 to that in 2004?
Make the answer very short. 0.89. What is the ratio of the CO2 emissions (% of total fuel combustion) of Nicaragua in 2003 to that in 2004?
Your response must be concise. 1.09. What is the ratio of the CO2 emissions (% of total fuel combustion) in Upper middle income in 2003 to that in 2005?
Your response must be concise. 1.04. What is the ratio of the CO2 emissions (% of total fuel combustion) in Algeria in 2003 to that in 2005?
Your answer should be compact. 0.97. What is the ratio of the CO2 emissions (% of total fuel combustion) of Bosnia and Herzegovina in 2003 to that in 2005?
Provide a short and direct response. 0.97. What is the ratio of the CO2 emissions (% of total fuel combustion) of Nicaragua in 2003 to that in 2005?
Make the answer very short. 1.07. What is the ratio of the CO2 emissions (% of total fuel combustion) in Upper middle income in 2004 to that in 2005?
Keep it short and to the point. 1.03. What is the ratio of the CO2 emissions (% of total fuel combustion) of Algeria in 2004 to that in 2005?
Your answer should be compact. 0.97. What is the ratio of the CO2 emissions (% of total fuel combustion) in Bosnia and Herzegovina in 2004 to that in 2005?
Your answer should be compact. 1.09. What is the ratio of the CO2 emissions (% of total fuel combustion) in Nicaragua in 2004 to that in 2005?
Offer a very short reply. 0.98. What is the difference between the highest and the second highest CO2 emissions (% of total fuel combustion) in Upper middle income?
Your response must be concise. 0.11. What is the difference between the highest and the second highest CO2 emissions (% of total fuel combustion) in Algeria?
Give a very brief answer. 1.01. What is the difference between the highest and the second highest CO2 emissions (% of total fuel combustion) in Bosnia and Herzegovina?
Offer a very short reply. 0.03. What is the difference between the highest and the second highest CO2 emissions (% of total fuel combustion) in Nicaragua?
Offer a terse response. 1.28. What is the difference between the highest and the lowest CO2 emissions (% of total fuel combustion) of Upper middle income?
Your answer should be compact. 1.42. What is the difference between the highest and the lowest CO2 emissions (% of total fuel combustion) of Algeria?
Your answer should be very brief. 4.2. What is the difference between the highest and the lowest CO2 emissions (% of total fuel combustion) in Bosnia and Herzegovina?
Offer a terse response. 1.7. What is the difference between the highest and the lowest CO2 emissions (% of total fuel combustion) in Nicaragua?
Your response must be concise. 5.79. 